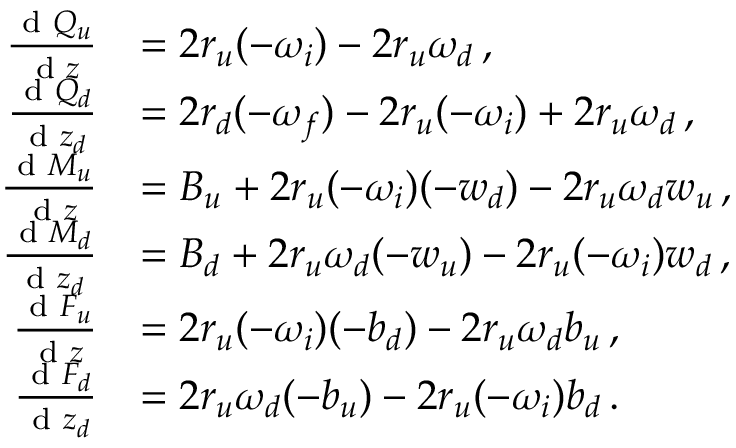<formula> <loc_0><loc_0><loc_500><loc_500>\begin{array} { r l } { \frac { d Q _ { u } } { d z } } & { = 2 r _ { u } ( - \omega _ { i } ) - 2 r _ { u } \omega _ { d } \, , } \\ { \frac { d Q _ { d } } { d z _ { d } } } & { = 2 r _ { d } ( - \omega _ { f } ) - 2 r _ { u } ( - \omega _ { i } ) + 2 r _ { u } \omega _ { d } \, , } \\ { \frac { d M _ { u } } { d z } } & { = B _ { u } + 2 r _ { u } ( - \omega _ { i } ) ( - w _ { d } ) - 2 r _ { u } \omega _ { d } w _ { u } \, , } \\ { \frac { d M _ { d } } { d z _ { d } } } & { = B _ { d } + 2 r _ { u } \omega _ { d } ( - w _ { u } ) - 2 r _ { u } ( - \omega _ { i } ) w _ { d } \, , } \\ { \frac { d F _ { u } } { d z } } & { = 2 r _ { u } ( - \omega _ { i } ) ( - b _ { d } ) - 2 r _ { u } \omega _ { d } b _ { u } \, , } \\ { \frac { d F _ { d } } { d z _ { d } } } & { = 2 r _ { u } \omega _ { d } ( - b _ { u } ) - 2 r _ { u } ( - \omega _ { i } ) b _ { d } \, . } \end{array}</formula> 